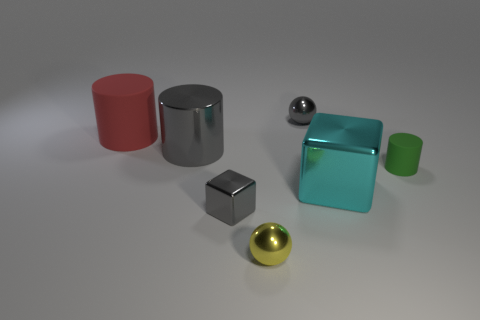There is a small sphere in front of the gray shiny thing that is right of the metallic sphere that is on the left side of the gray metallic sphere; what is it made of?
Offer a terse response. Metal. Are there any other things that are the same shape as the big red matte object?
Give a very brief answer. Yes. There is a shiny object that is the same shape as the red matte object; what is its color?
Offer a terse response. Gray. Does the metal thing that is to the right of the gray shiny sphere have the same color as the large object that is behind the large shiny cylinder?
Your answer should be very brief. No. Is the number of green matte objects on the left side of the cyan thing greater than the number of big gray metallic cylinders?
Provide a short and direct response. No. How many other things are the same size as the gray block?
Offer a very short reply. 3. What number of matte objects are both on the right side of the big red rubber cylinder and behind the tiny green rubber cylinder?
Provide a succinct answer. 0. Do the tiny thing that is behind the big rubber object and the cyan cube have the same material?
Your answer should be very brief. Yes. The matte thing that is on the left side of the thing in front of the tiny gray shiny object that is in front of the cyan metal cube is what shape?
Keep it short and to the point. Cylinder. Are there the same number of cyan blocks that are on the left side of the yellow ball and tiny matte objects in front of the big cyan metallic object?
Give a very brief answer. Yes. 